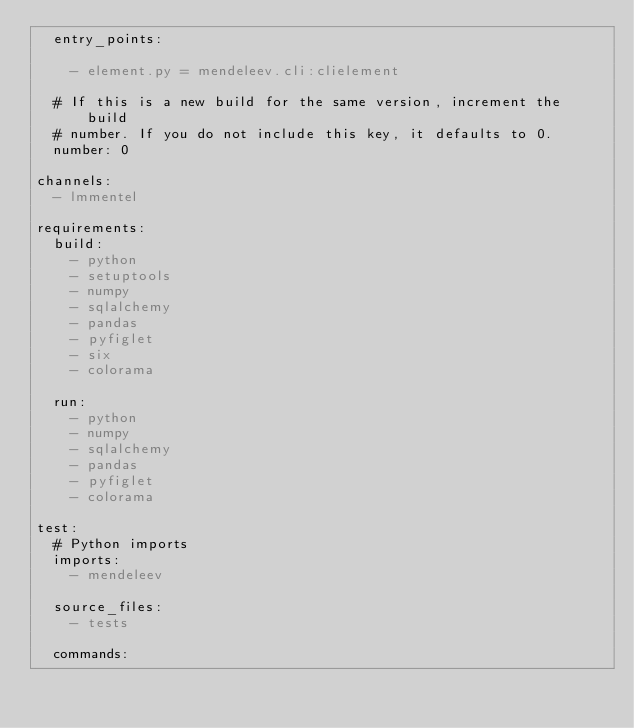<code> <loc_0><loc_0><loc_500><loc_500><_YAML_>  entry_points:

    - element.py = mendeleev.cli:clielement

  # If this is a new build for the same version, increment the build
  # number. If you do not include this key, it defaults to 0.
  number: 0

channels:
  - lmmentel

requirements:
  build:
    - python
    - setuptools
    - numpy
    - sqlalchemy
    - pandas
    - pyfiglet
    - six
    - colorama

  run:
    - python
    - numpy
    - sqlalchemy
    - pandas
    - pyfiglet
    - colorama

test:
  # Python imports
  imports:
    - mendeleev

  source_files:
    - tests

  commands:</code> 